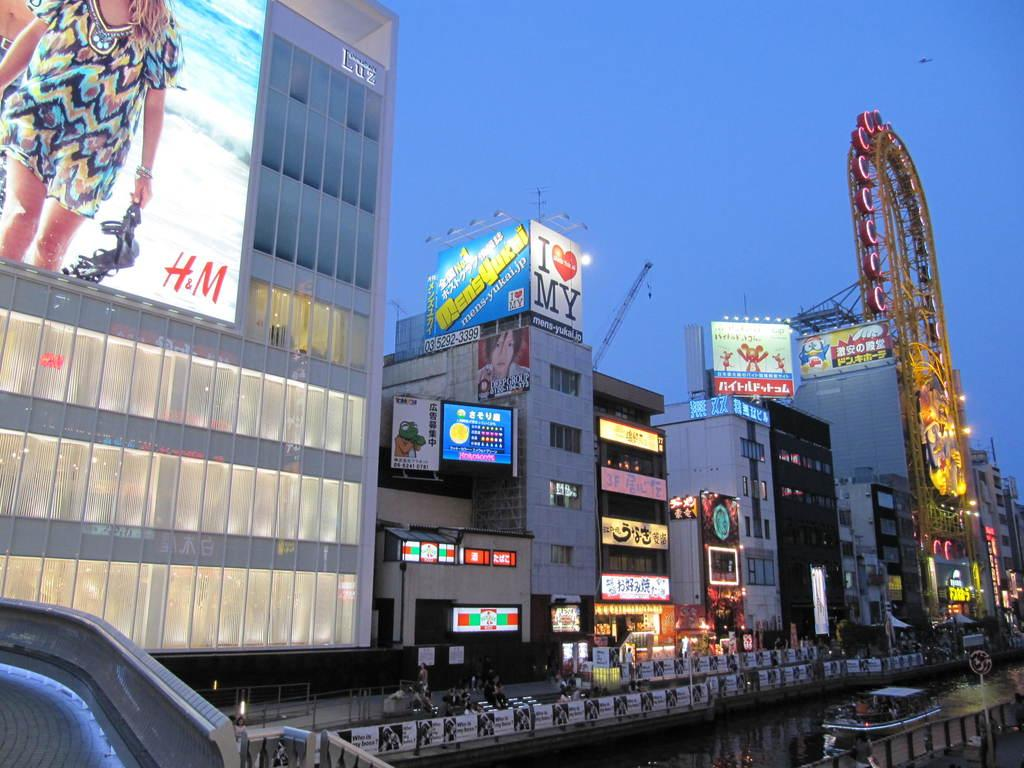What type of structures can be seen in the image? There are buildings in the image. What else is present on the buildings in the image? There are hoardings on the buildings. What can be seen illuminating the scene in the image? There are lights in the image. Can you describe the people in the image? There is a group of people in the image. What is located at the bottom of the image? There is a boat on the water at the bottom of the image. What type of machinery is visible in the background of the image? There are cranes visible in the background of the image. What type of shade is provided by the boat in the image? There is no shade provided by the boat in the image, as it is on the water and not positioned to provide shade. How does the group of people show respect in the image? There is no indication of respect being shown by the group of people in the image. What color is the shirt worn by the crane operator in the image? There is no crane operator visible in the image, and therefore no shirt to describe. 